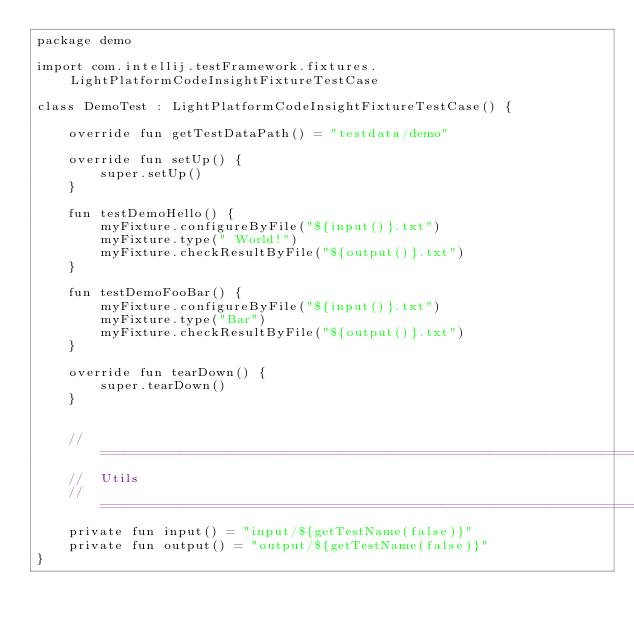Convert code to text. <code><loc_0><loc_0><loc_500><loc_500><_Kotlin_>package demo

import com.intellij.testFramework.fixtures.LightPlatformCodeInsightFixtureTestCase

class DemoTest : LightPlatformCodeInsightFixtureTestCase() {

    override fun getTestDataPath() = "testdata/demo"

    override fun setUp() {
        super.setUp()
    }

    fun testDemoHello() {
        myFixture.configureByFile("${input()}.txt")
        myFixture.type(" World!")
        myFixture.checkResultByFile("${output()}.txt")
    }

    fun testDemoFooBar() {
        myFixture.configureByFile("${input()}.txt")
        myFixture.type("Bar")
        myFixture.checkResultByFile("${output()}.txt")
    }

    override fun tearDown() {
        super.tearDown()
    }


    //==================================================================================================================
    //  Utils
    //==================================================================================================================
    private fun input() = "input/${getTestName(false)}"
    private fun output() = "output/${getTestName(false)}"
}</code> 